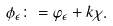<formula> <loc_0><loc_0><loc_500><loc_500>\phi _ { \epsilon } \colon = \varphi _ { \epsilon } + k \chi .</formula> 